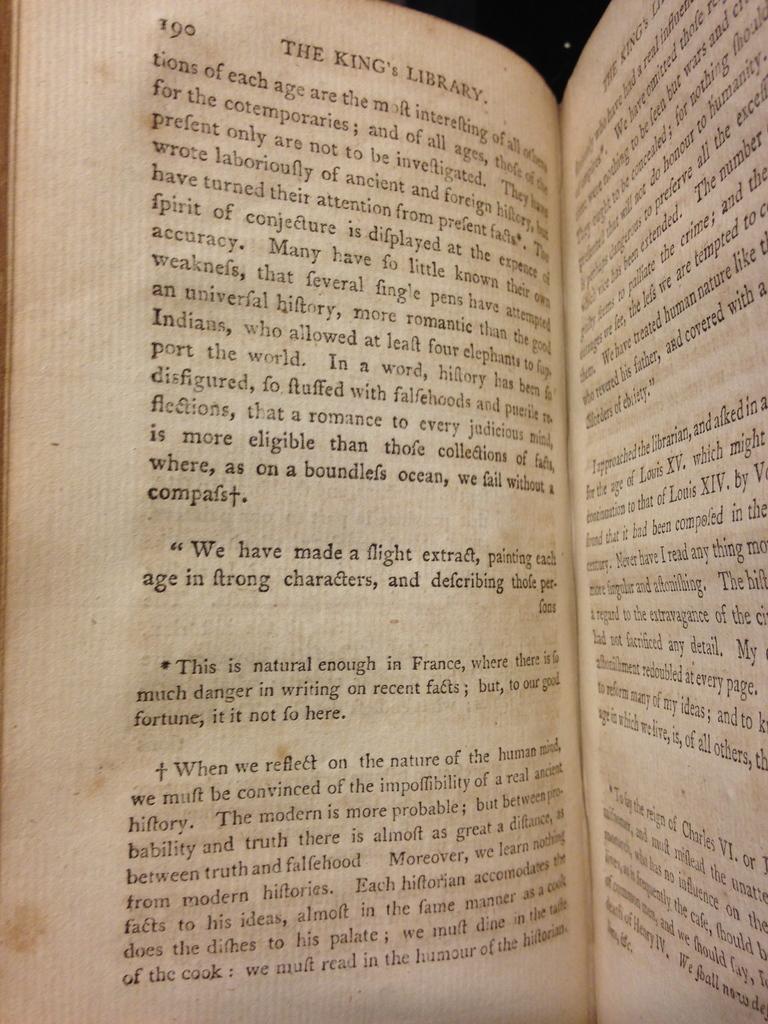What is the title of this novel?
Provide a short and direct response. The king's library. What page does the image show?
Your answer should be compact. 190. 